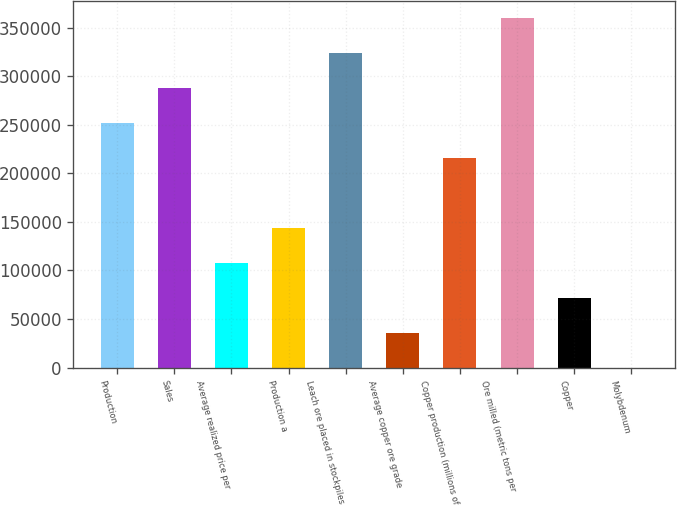Convert chart to OTSL. <chart><loc_0><loc_0><loc_500><loc_500><bar_chart><fcel>Production<fcel>Sales<fcel>Average realized price per<fcel>Production a<fcel>Leach ore placed in stockpiles<fcel>Average copper ore grade<fcel>Copper production (millions of<fcel>Ore milled (metric tons per<fcel>Copper<fcel>Molybdenum<nl><fcel>252070<fcel>288080<fcel>108030<fcel>144040<fcel>324090<fcel>36010<fcel>216060<fcel>360100<fcel>72020<fcel>0.02<nl></chart> 